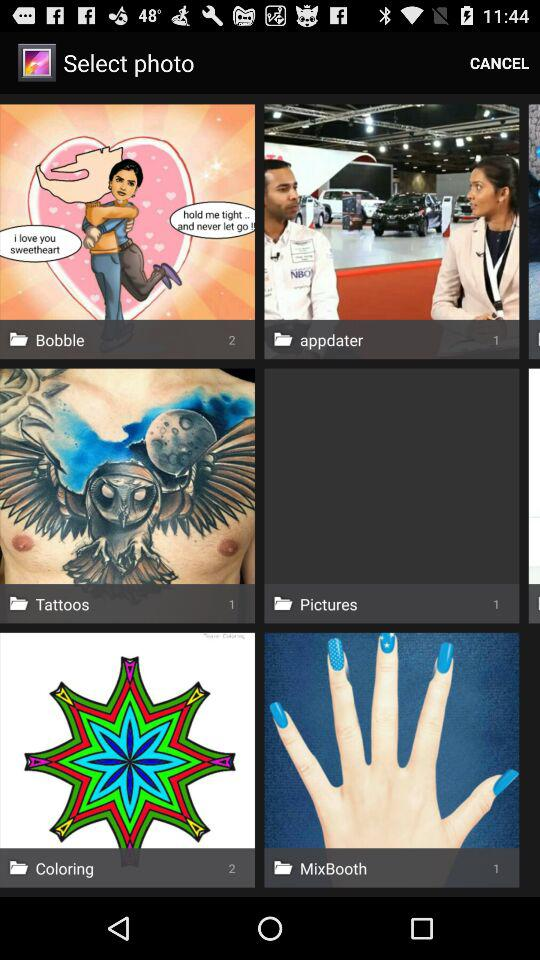How many images are there in the MixBooth folder? There is 1 image. 